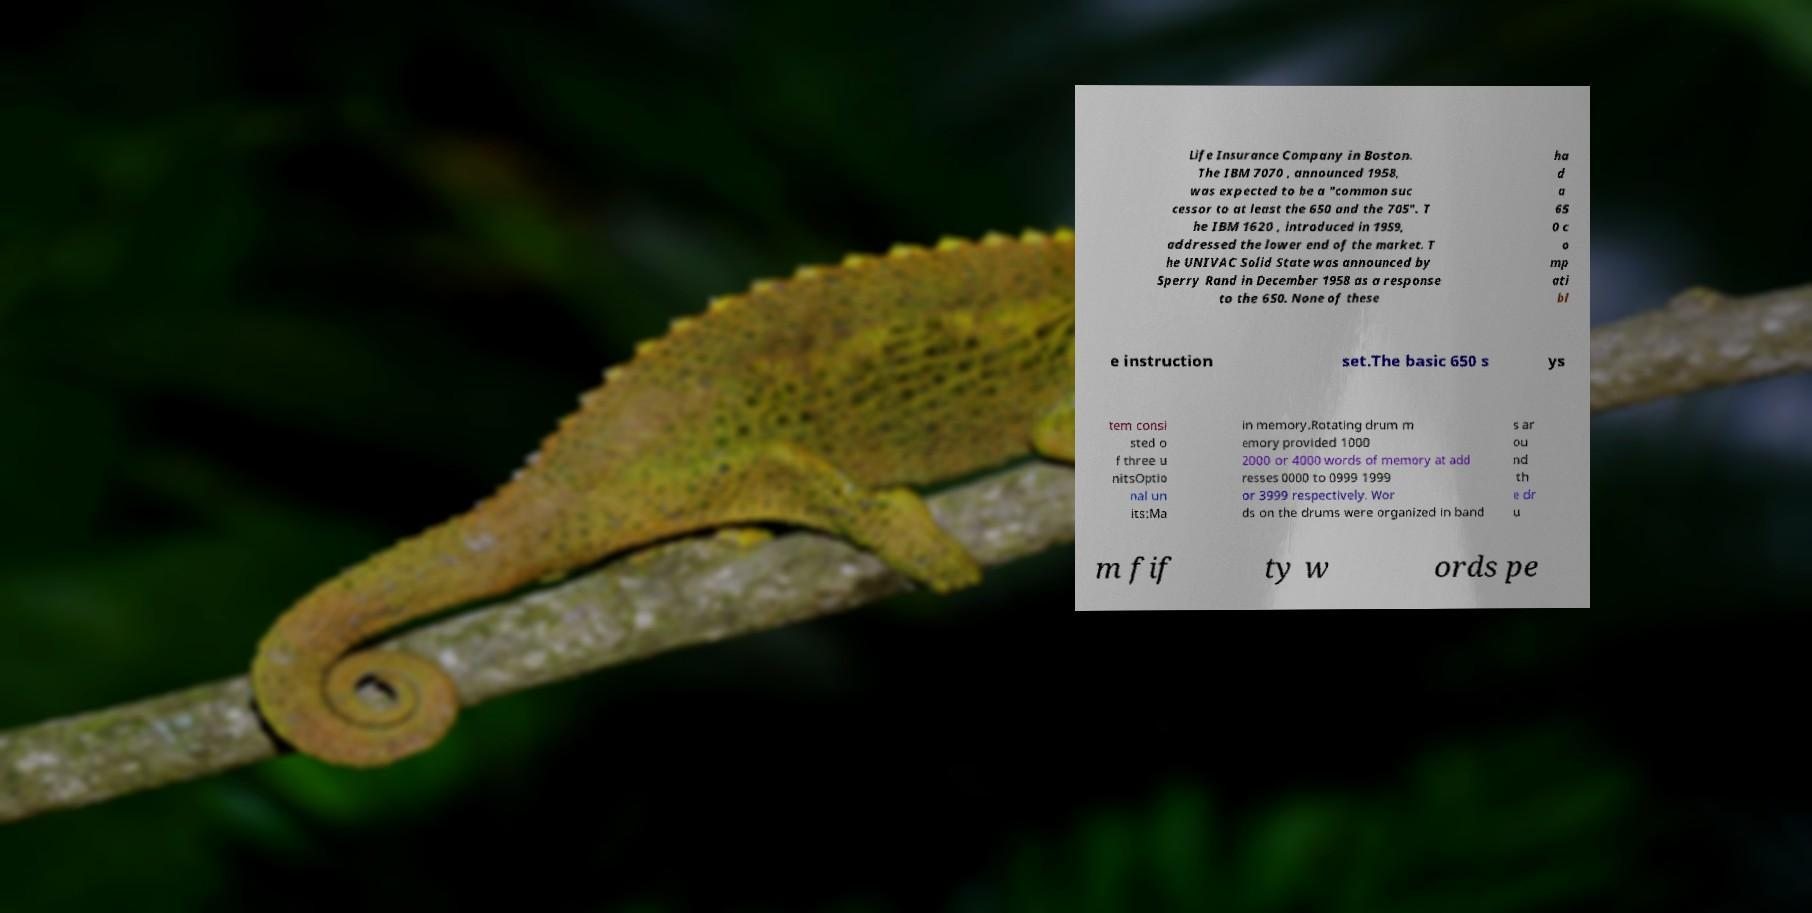What messages or text are displayed in this image? I need them in a readable, typed format. Life Insurance Company in Boston. The IBM 7070 , announced 1958, was expected to be a "common suc cessor to at least the 650 and the 705". T he IBM 1620 , introduced in 1959, addressed the lower end of the market. T he UNIVAC Solid State was announced by Sperry Rand in December 1958 as a response to the 650. None of these ha d a 65 0 c o mp ati bl e instruction set.The basic 650 s ys tem consi sted o f three u nitsOptio nal un its:Ma in memory.Rotating drum m emory provided 1000 2000 or 4000 words of memory at add resses 0000 to 0999 1999 or 3999 respectively. Wor ds on the drums were organized in band s ar ou nd th e dr u m fif ty w ords pe 